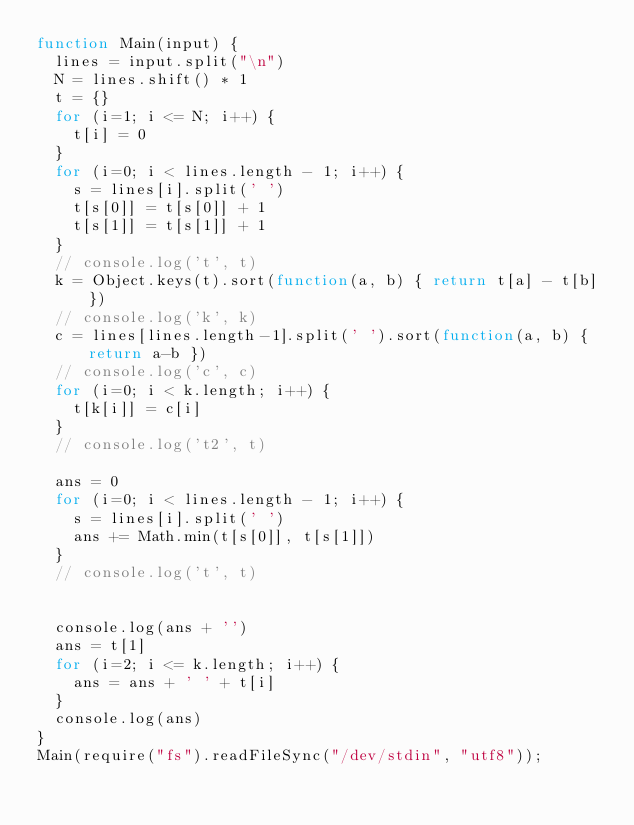<code> <loc_0><loc_0><loc_500><loc_500><_JavaScript_>function Main(input) {
  lines = input.split("\n")
  N = lines.shift() * 1
  t = {}
  for (i=1; i <= N; i++) {
    t[i] = 0
  }
  for (i=0; i < lines.length - 1; i++) {
    s = lines[i].split(' ')
    t[s[0]] = t[s[0]] + 1
    t[s[1]] = t[s[1]] + 1
  }
  // console.log('t', t)
  k = Object.keys(t).sort(function(a, b) { return t[a] - t[b] })
  // console.log('k', k)
  c = lines[lines.length-1].split(' ').sort(function(a, b) { return a-b })
  // console.log('c', c)
  for (i=0; i < k.length; i++) {
    t[k[i]] = c[i]
  }
  // console.log('t2', t)

  ans = 0
  for (i=0; i < lines.length - 1; i++) {
    s = lines[i].split(' ')
    ans += Math.min(t[s[0]], t[s[1]])
  }
  // console.log('t', t)

  
  console.log(ans + '')
  ans = t[1]
  for (i=2; i <= k.length; i++) {
    ans = ans + ' ' + t[i]
  }
  console.log(ans)
}
Main(require("fs").readFileSync("/dev/stdin", "utf8"));</code> 